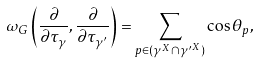Convert formula to latex. <formula><loc_0><loc_0><loc_500><loc_500>{ \omega _ { G } } \left ( \frac { \partial } { \partial \tau _ { \gamma } } , \frac { \partial } { \partial \tau _ { \gamma ^ { \prime } } } \right ) = \sum _ { p \in ( \gamma ^ { X } \cap { \gamma ^ { \prime } } ^ { X } ) } \cos \theta _ { p } ,</formula> 